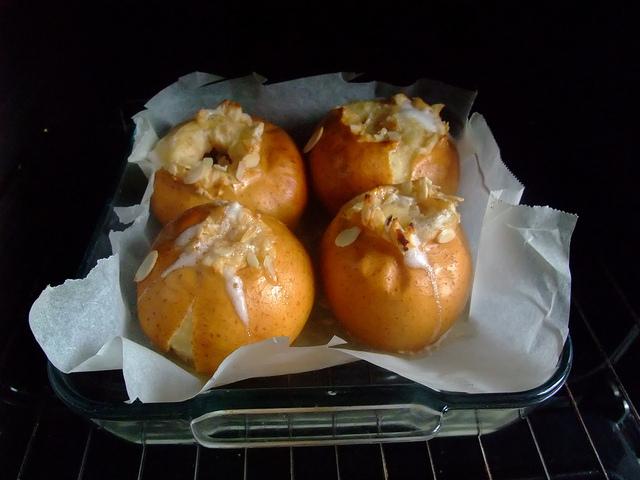Is this food fully cooked?
Concise answer only. Yes. What fruit do you think this is?
Write a very short answer. Apple. What color is the pan?
Be succinct. Clear. How many donuts are there?
Write a very short answer. 4. What type of paper is being used as a liner?
Concise answer only. Wax. 